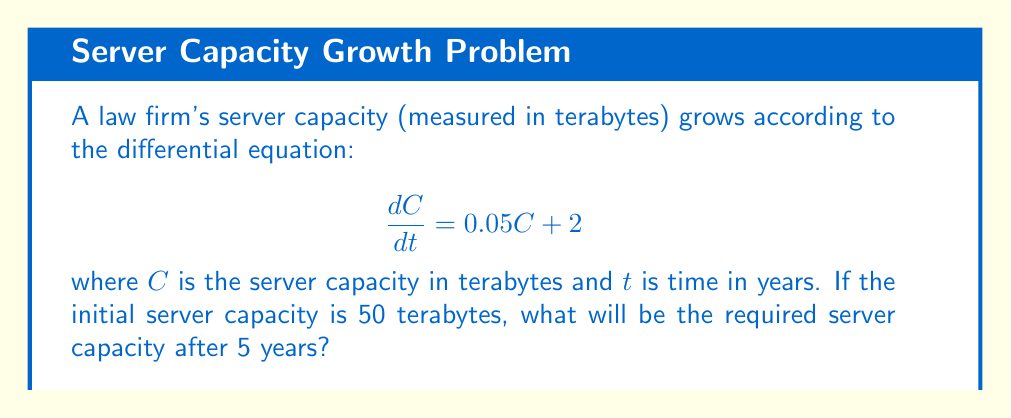Teach me how to tackle this problem. To solve this first-order linear differential equation, we follow these steps:

1) The general form of a first-order linear differential equation is:

   $$\frac{dy}{dx} + P(x)y = Q(x)$$

   In our case, $\frac{dC}{dt} = 0.05C + 2$, so $P(t) = -0.05$ and $Q(t) = 2$.

2) The integrating factor is $e^{\int P(t) dt} = e^{-0.05t}$.

3) Multiply both sides of the equation by the integrating factor:

   $$e^{-0.05t}\frac{dC}{dt} + 0.05e^{-0.05t}C = 2e^{-0.05t}$$

4) The left side is now the derivative of $e^{-0.05t}C$, so we can write:

   $$\frac{d}{dt}(e^{-0.05t}C) = 2e^{-0.05t}$$

5) Integrate both sides:

   $$e^{-0.05t}C = -40e^{-0.05t} + K$$

6) Solve for $C$:

   $$C = -40 + Ke^{0.05t}$$

7) Use the initial condition $C(0) = 50$ to find $K$:

   $$50 = -40 + K$$
   $$K = 90$$

8) The particular solution is:

   $$C = -40 + 90e^{0.05t}$$

9) To find the capacity after 5 years, substitute $t = 5$:

   $$C(5) = -40 + 90e^{0.05(5)} = -40 + 90e^{0.25} \approx 74.62$$

Therefore, the required server capacity after 5 years will be approximately 74.62 terabytes.
Answer: 74.62 terabytes 